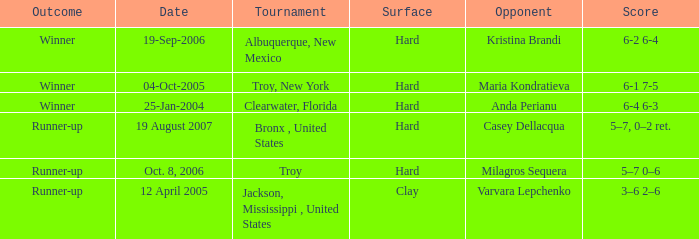What was the surface of the game that resulted in a final score of 6-1 7-5? Hard. 